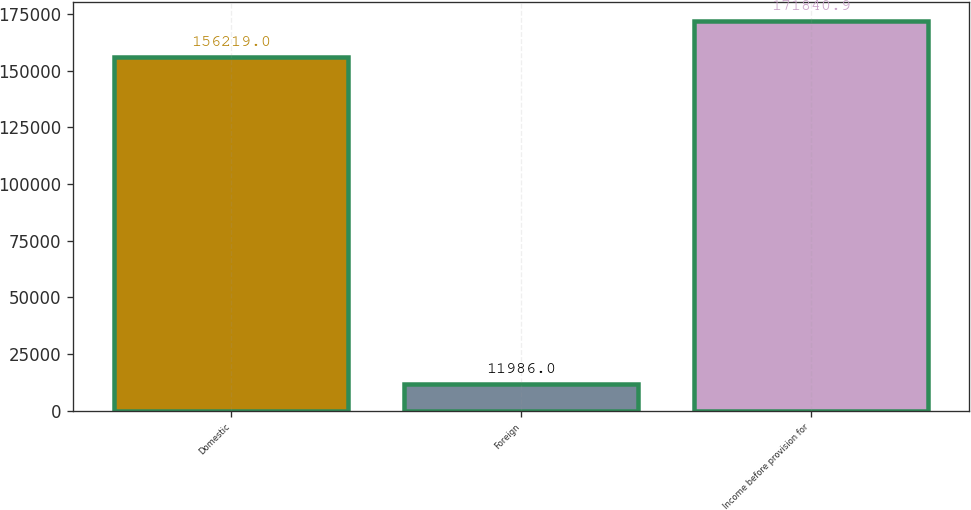<chart> <loc_0><loc_0><loc_500><loc_500><bar_chart><fcel>Domestic<fcel>Foreign<fcel>Income before provision for<nl><fcel>156219<fcel>11986<fcel>171841<nl></chart> 